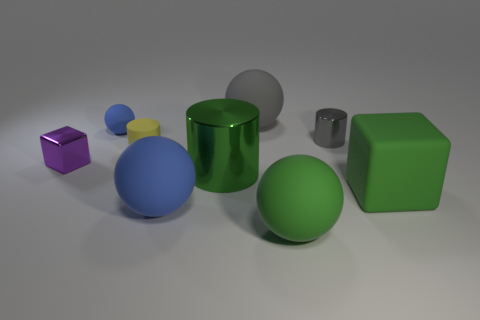What number of objects are either small shiny objects that are to the right of the gray rubber sphere or small matte spheres?
Ensure brevity in your answer.  2. What shape is the green rubber object behind the large blue rubber thing in front of the small gray object?
Give a very brief answer. Cube. There is a gray cylinder; is its size the same as the block that is behind the large green metal object?
Make the answer very short. Yes. There is a large ball that is behind the yellow cylinder; what is its material?
Keep it short and to the point. Rubber. How many tiny things are to the left of the tiny metallic cylinder and behind the tiny purple block?
Offer a terse response. 2. There is a blue thing that is the same size as the purple shiny object; what is it made of?
Offer a very short reply. Rubber. Is the size of the blue rubber thing that is in front of the large rubber cube the same as the green object that is left of the large green matte ball?
Your answer should be very brief. Yes. Are there any tiny matte things on the left side of the small yellow thing?
Your answer should be compact. Yes. There is a small matte cylinder that is in front of the metal object that is behind the purple shiny cube; what is its color?
Provide a succinct answer. Yellow. Are there fewer tiny gray things than cyan shiny balls?
Your response must be concise. No. 